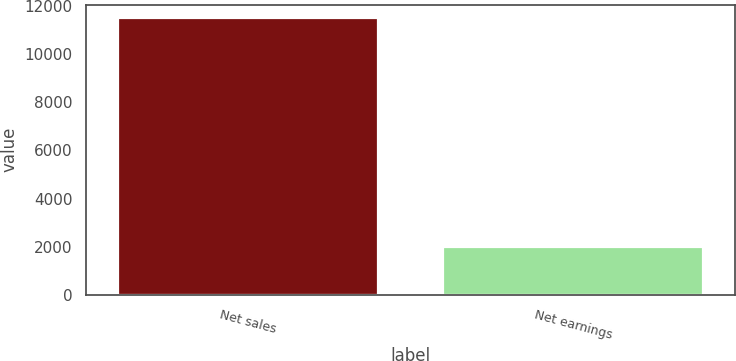<chart> <loc_0><loc_0><loc_500><loc_500><bar_chart><fcel>Net sales<fcel>Net earnings<nl><fcel>11477<fcel>1975<nl></chart> 